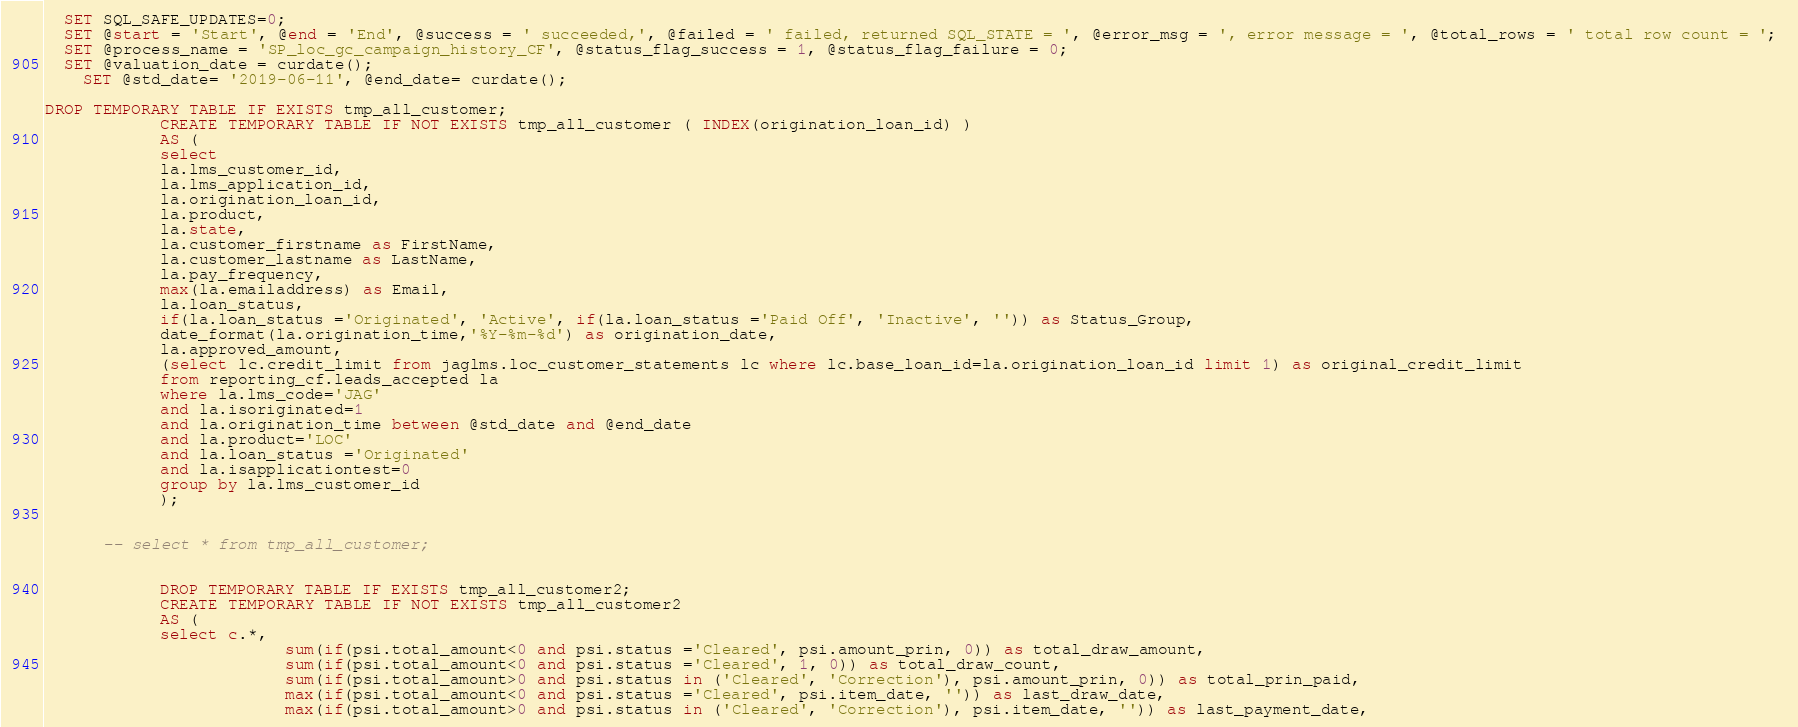<code> <loc_0><loc_0><loc_500><loc_500><_SQL_>
  SET SQL_SAFE_UPDATES=0;
  SET @start = 'Start', @end = 'End', @success = ' succeeded,', @failed = ' failed, returned SQL_STATE = ', @error_msg = ', error message = ', @total_rows = ' total row count = '; 
  SET @process_name = 'SP_loc_gc_campaign_history_CF', @status_flag_success = 1, @status_flag_failure = 0;
  SET @valuation_date = curdate();  
	SET @std_date= '2019-06-11', @end_date= curdate();

DROP TEMPORARY TABLE IF EXISTS tmp_all_customer;
			CREATE TEMPORARY TABLE IF NOT EXISTS tmp_all_customer ( INDEX(origination_loan_id) ) 
			AS (
			select 
			la.lms_customer_id, 
			la.lms_application_id,
			la.origination_loan_id,
			la.product,
			la.state,
			la.customer_firstname as FirstName, 
			la.customer_lastname as LastName, 
			la.pay_frequency,
			max(la.emailaddress) as Email,
			la.loan_status,
			if(la.loan_status ='Originated', 'Active', if(la.loan_status ='Paid Off', 'Inactive', '')) as Status_Group,
			date_format(la.origination_time,'%Y-%m-%d') as origination_date,
			la.approved_amount,
			(select lc.credit_limit from jaglms.loc_customer_statements lc where lc.base_loan_id=la.origination_loan_id limit 1) as original_credit_limit
			from reporting_cf.leads_accepted la 
			where la.lms_code='JAG' 
			and la.isoriginated=1
			and la.origination_time between @std_date and @end_date
			and la.product='LOC'
			and la.loan_status ='Originated'
			and la.isapplicationtest=0
			group by la.lms_customer_id
			);
      
      
      -- select * from tmp_all_customer;
      

			DROP TEMPORARY TABLE IF EXISTS tmp_all_customer2;
			CREATE TEMPORARY TABLE IF NOT EXISTS tmp_all_customer2 
			AS (
			select c.*,
						 sum(if(psi.total_amount<0 and psi.status ='Cleared', psi.amount_prin, 0)) as total_draw_amount,
						 sum(if(psi.total_amount<0 and psi.status ='Cleared', 1, 0)) as total_draw_count,
						 sum(if(psi.total_amount>0 and psi.status in ('Cleared', 'Correction'), psi.amount_prin, 0)) as total_prin_paid,
						 max(if(psi.total_amount<0 and psi.status ='Cleared', psi.item_date, '')) as last_draw_date,
						 max(if(psi.total_amount>0 and psi.status in ('Cleared', 'Correction'), psi.item_date, '')) as last_payment_date,</code> 